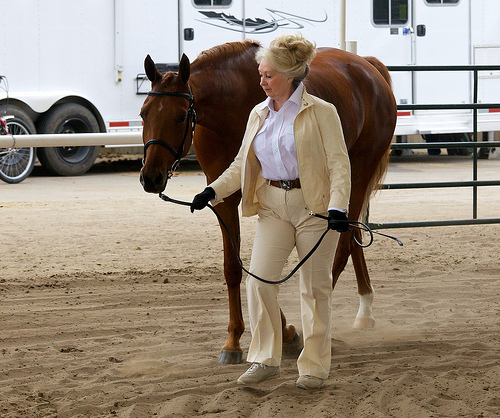<image>
Is there a animal behind the women? Yes. From this viewpoint, the animal is positioned behind the women, with the women partially or fully occluding the animal. Is the woman to the right of the horse? No. The woman is not to the right of the horse. The horizontal positioning shows a different relationship. Is the woman in front of the horse? Yes. The woman is positioned in front of the horse, appearing closer to the camera viewpoint. 